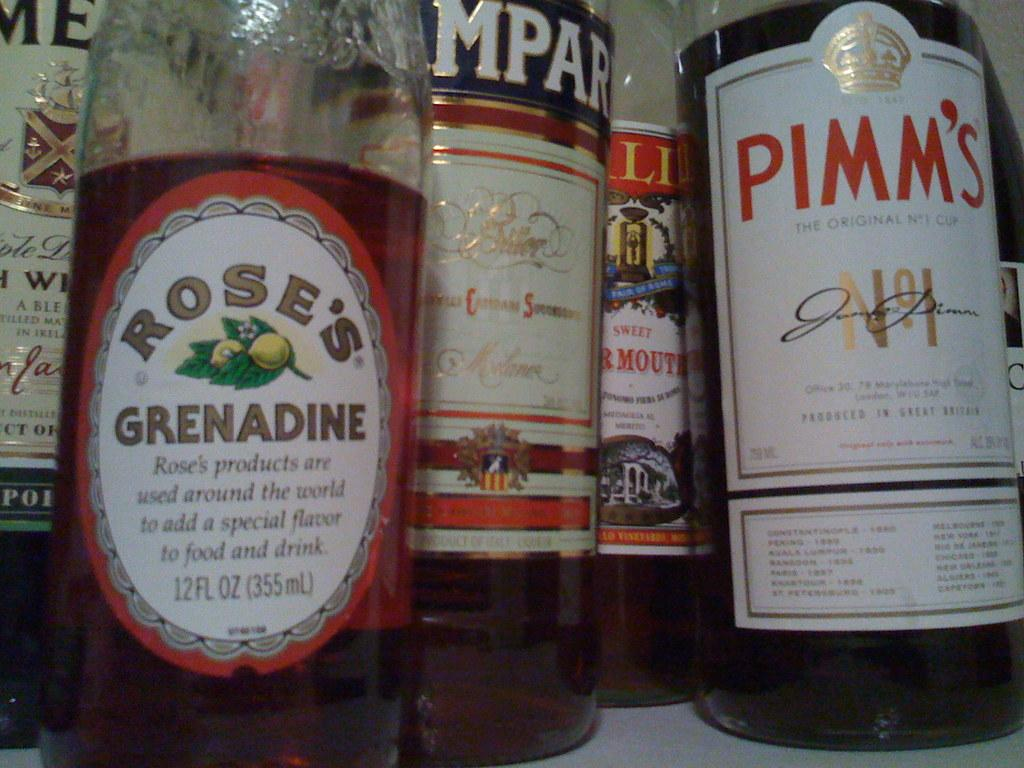What type of bottles are visible in the image? There are liquor bottles in the image. Where are the liquor bottles located? The liquor bottles are on the floor. What is inside the liquor bottles? The liquor bottles contain beverages. Can you describe the setting of the image? The image appears to be taken inside a shop. What type of history can be seen in the image? There is no history visible in the image; it features liquor bottles on the floor inside a shop. 